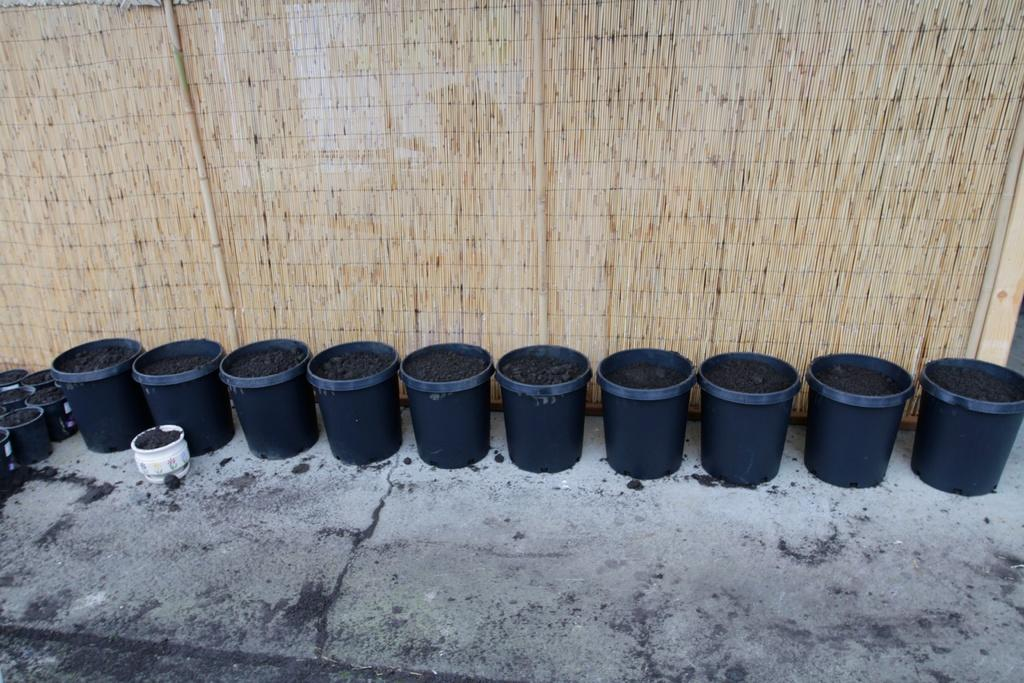What objects are present in the image that contain soil? There are pots with soil in the image. What can be seen on the wall in the background of the image? There are sticks on the wall in the background of the image. What is visible at the bottom of the image? The ground is visible at the bottom of the image. What type of wool is being used to create a route for the snakes in the image? There is no wool, route, or snakes present in the image. 